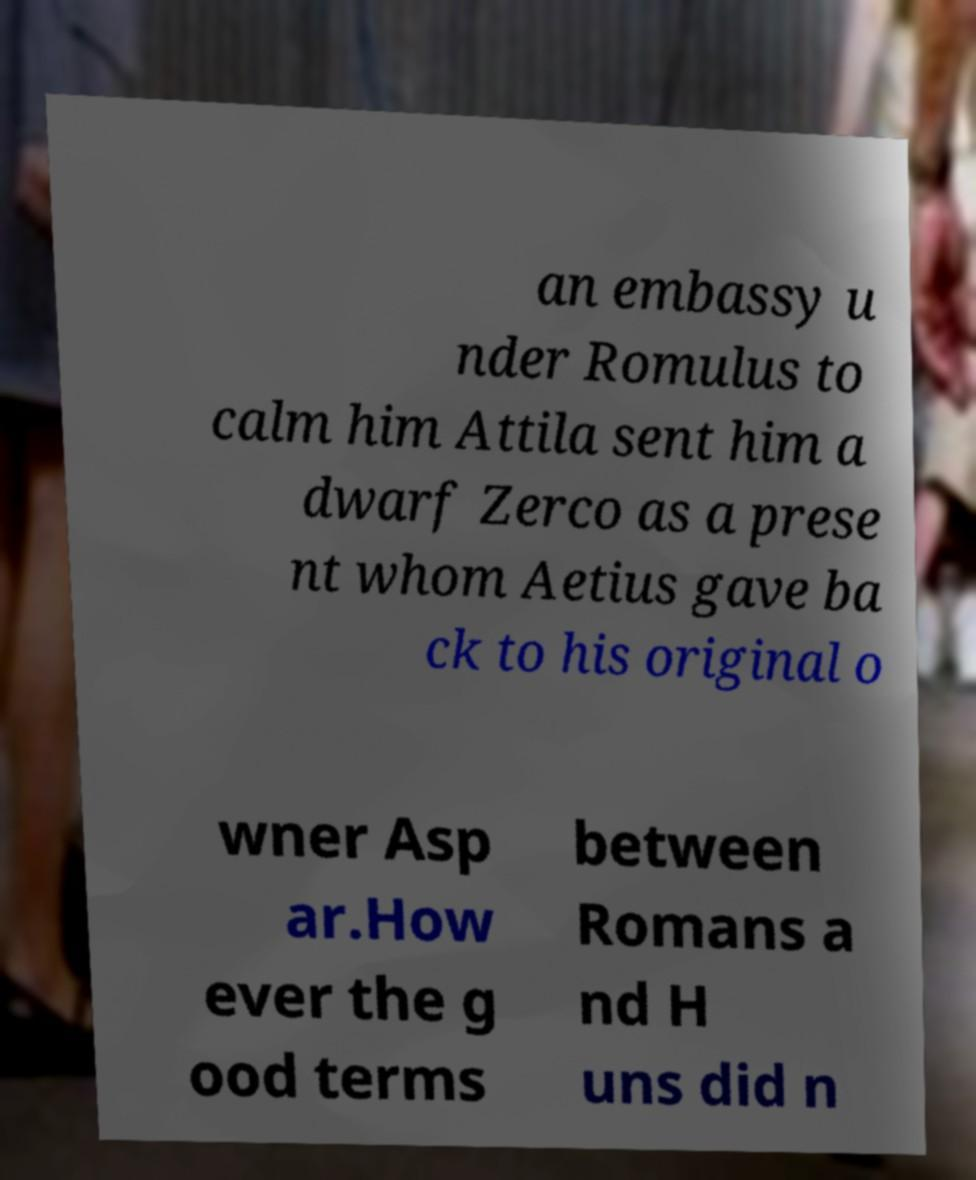There's text embedded in this image that I need extracted. Can you transcribe it verbatim? an embassy u nder Romulus to calm him Attila sent him a dwarf Zerco as a prese nt whom Aetius gave ba ck to his original o wner Asp ar.How ever the g ood terms between Romans a nd H uns did n 